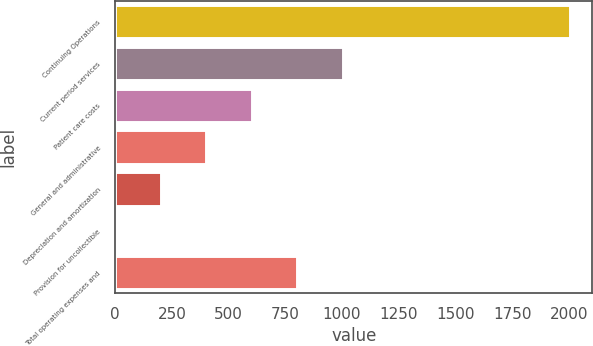<chart> <loc_0><loc_0><loc_500><loc_500><bar_chart><fcel>Continuing Operations<fcel>Current period services<fcel>Patient care costs<fcel>General and administrative<fcel>Depreciation and amortization<fcel>Provision for uncollectible<fcel>Total operating expenses and<nl><fcel>2004<fcel>1003<fcel>602.6<fcel>402.4<fcel>202.2<fcel>2<fcel>802.8<nl></chart> 